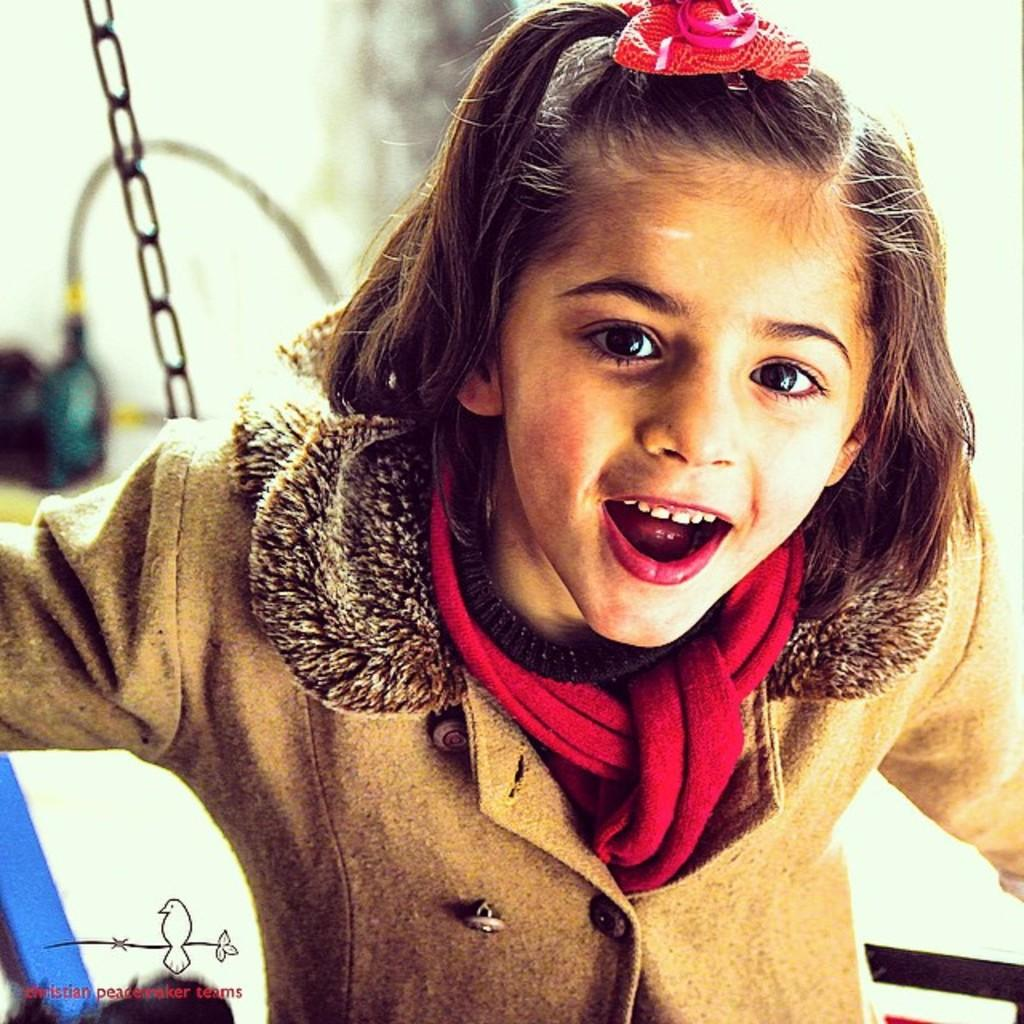Who is the main subject in the picture? There is a small girl in the picture. What is the girl wearing? The girl is wearing a brown coat. What is the girl's facial expression? The girl is smiling. What is the girl doing in the picture? The girl is giving a pose. What can be seen in the background of the image? There is a chain visible in the background. How is the background of the image? The background is blurred. What type of bun is the girl holding in the image? There is no bun present in the image. What observation can be made about the birds in the image? There are no birds present in the image. 